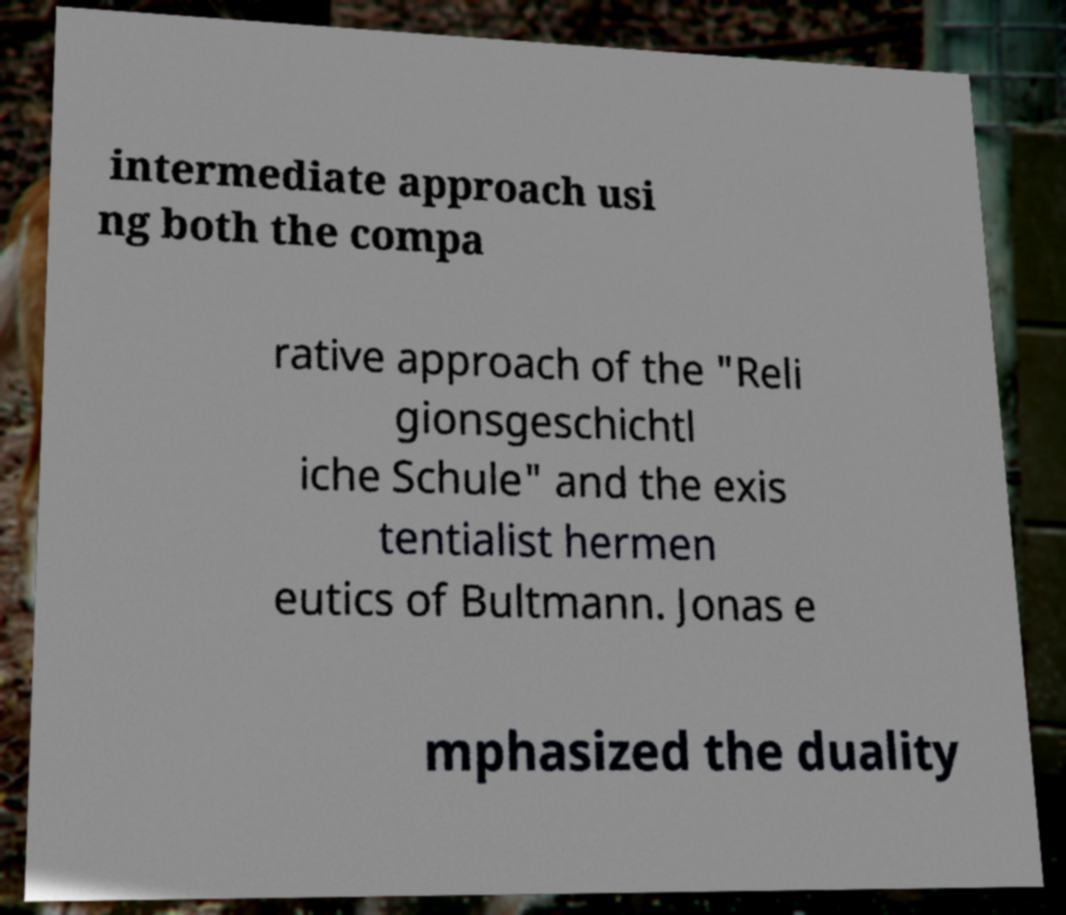Could you assist in decoding the text presented in this image and type it out clearly? intermediate approach usi ng both the compa rative approach of the "Reli gionsgeschichtl iche Schule" and the exis tentialist hermen eutics of Bultmann. Jonas e mphasized the duality 